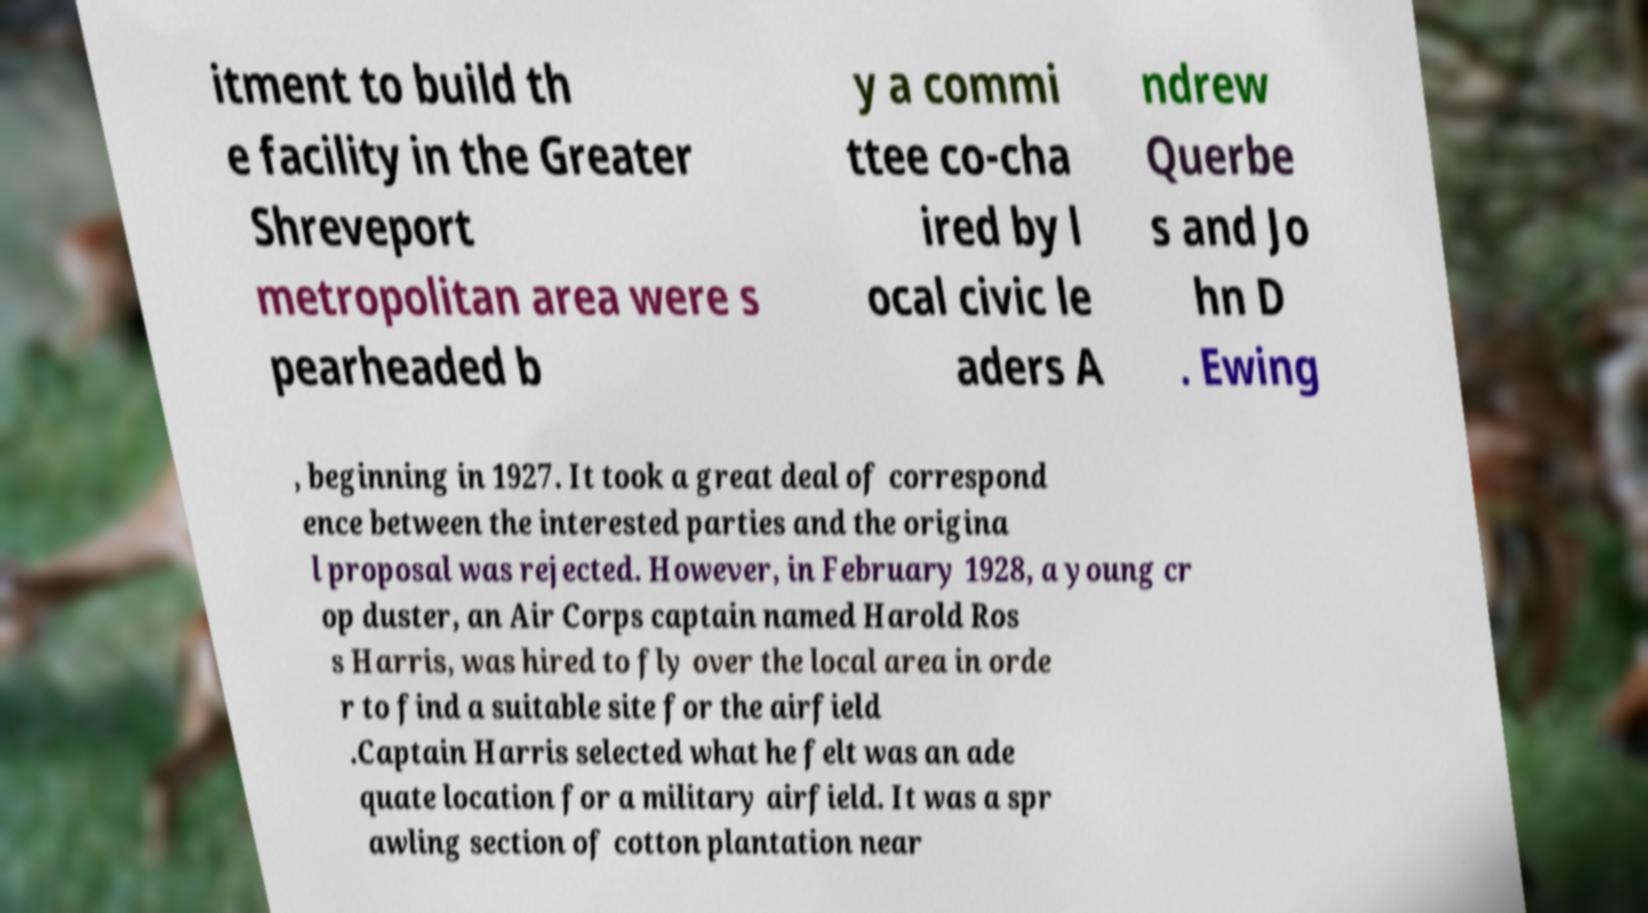Can you read and provide the text displayed in the image?This photo seems to have some interesting text. Can you extract and type it out for me? itment to build th e facility in the Greater Shreveport metropolitan area were s pearheaded b y a commi ttee co-cha ired by l ocal civic le aders A ndrew Querbe s and Jo hn D . Ewing , beginning in 1927. It took a great deal of correspond ence between the interested parties and the origina l proposal was rejected. However, in February 1928, a young cr op duster, an Air Corps captain named Harold Ros s Harris, was hired to fly over the local area in orde r to find a suitable site for the airfield .Captain Harris selected what he felt was an ade quate location for a military airfield. It was a spr awling section of cotton plantation near 